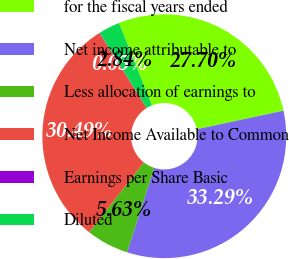<chart> <loc_0><loc_0><loc_500><loc_500><pie_chart><fcel>for the fiscal years ended<fcel>Net income attributable to<fcel>Less allocation of earnings to<fcel>Net Income Available to Common<fcel>Earnings per Share Basic<fcel>Diluted<nl><fcel>27.7%<fcel>33.29%<fcel>5.63%<fcel>30.49%<fcel>0.05%<fcel>2.84%<nl></chart> 